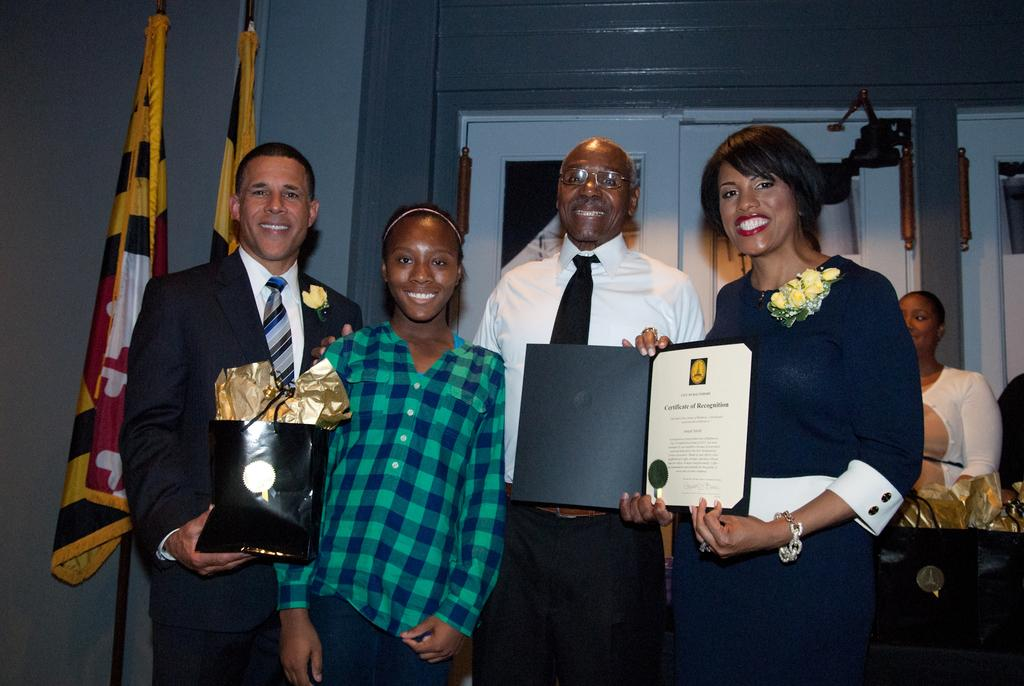What type of structure can be seen in the image? There is a wall in the image. Are there any openings in the wall? Yes, there are doors in the image. What else is present in the image besides the wall and doors? There are flags, a table, and people standing in the image. Can you describe the people in the image? There are people standing in the image, and a woman is standing on the right side of the image. What is the woman holding in the image? The woman is holding a file. What type of soda is being served at the bath in the image? There is no soda or bath present in the image. 